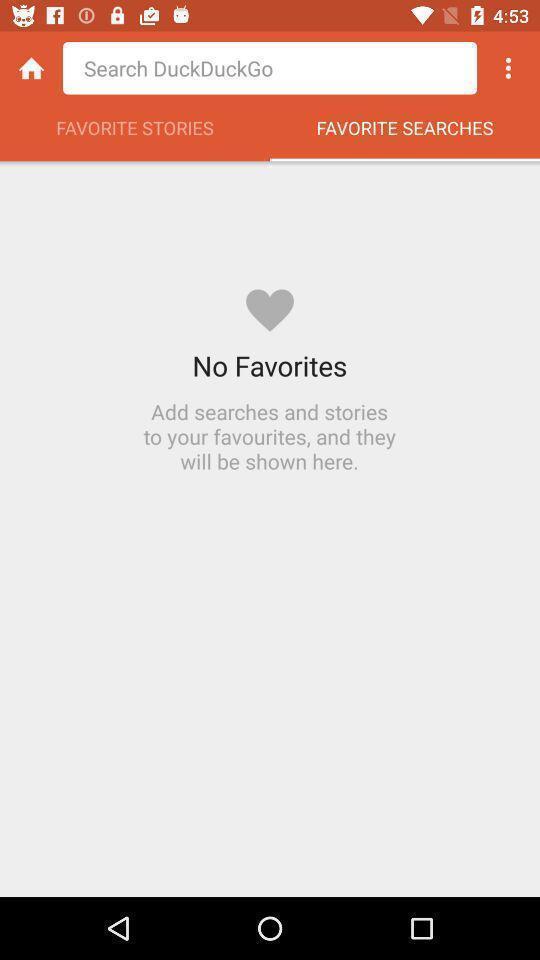Summarize the main components in this picture. Page showing interface of a mobile browser app. 